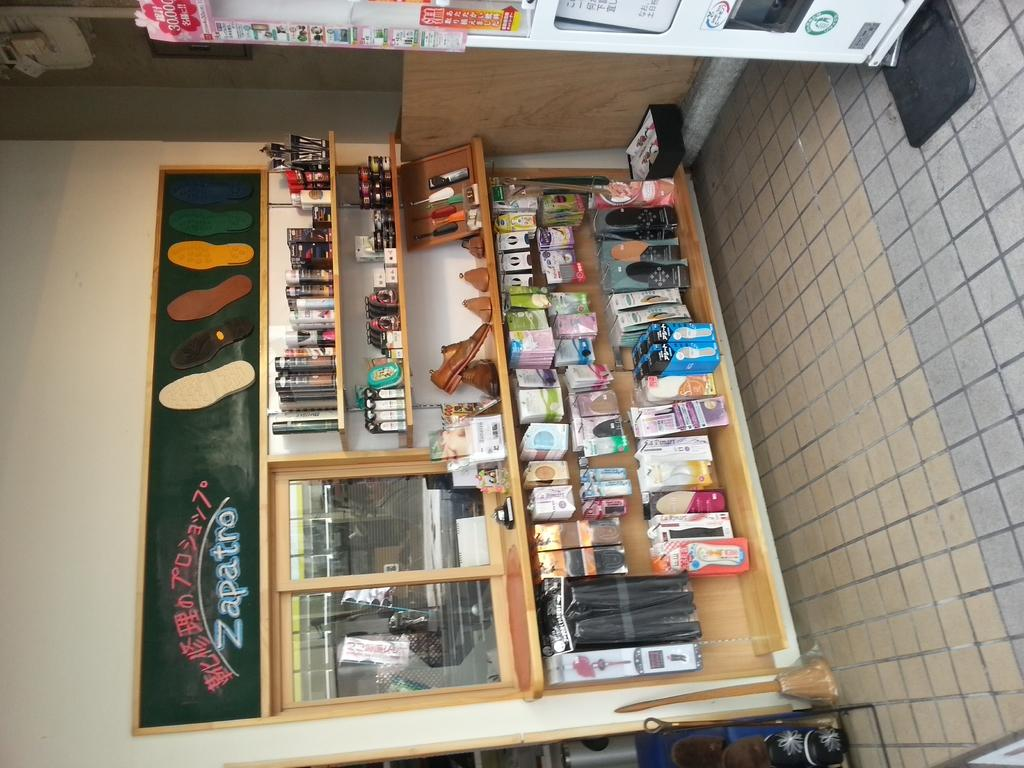Provide a one-sentence caption for the provided image. A vendor stand called Zapatro sells many things. 